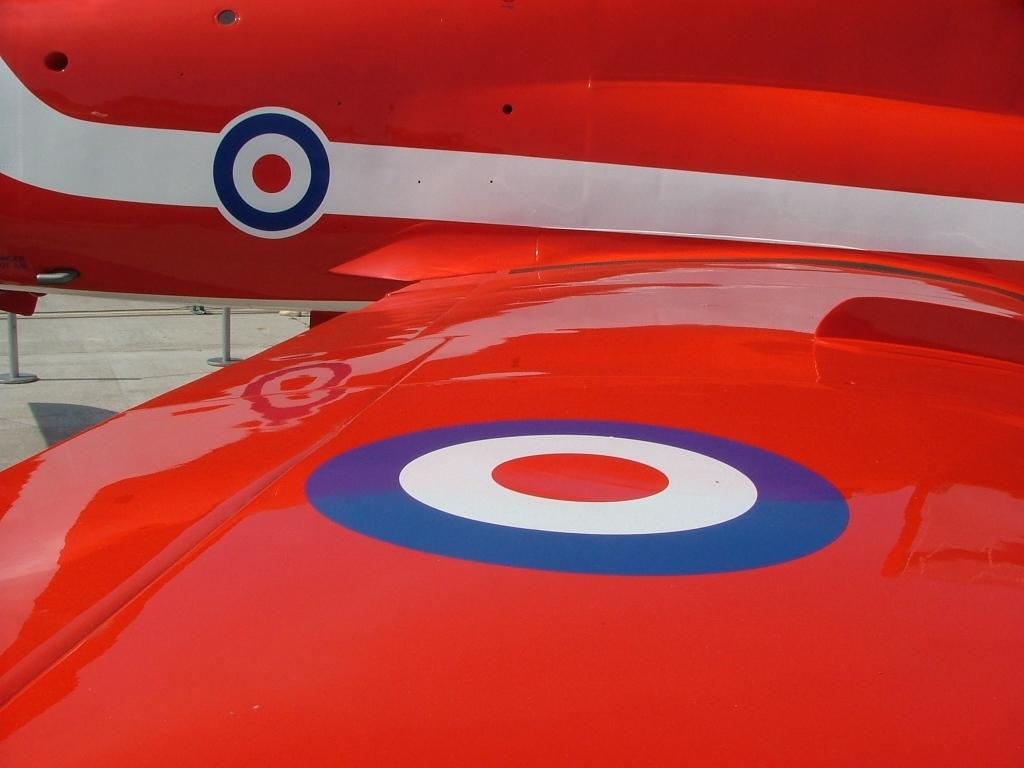What is the main subject of the image? The main subject of the image is an airplane. What color is the airplane? The airplane is red in color. What can be seen on the left side of the image? There is a floor on the left side of the image. What type of wood can be seen on the neck of the airplane in the image? There is no wood or neck present on the airplane in the image; it is a solid structure. Can you see any branches growing from the airplane in the image? There are no branches present in the image; it features an airplane and a floor. 